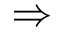Convert formula to latex. <formula><loc_0><loc_0><loc_500><loc_500>\Rightarrow</formula> 